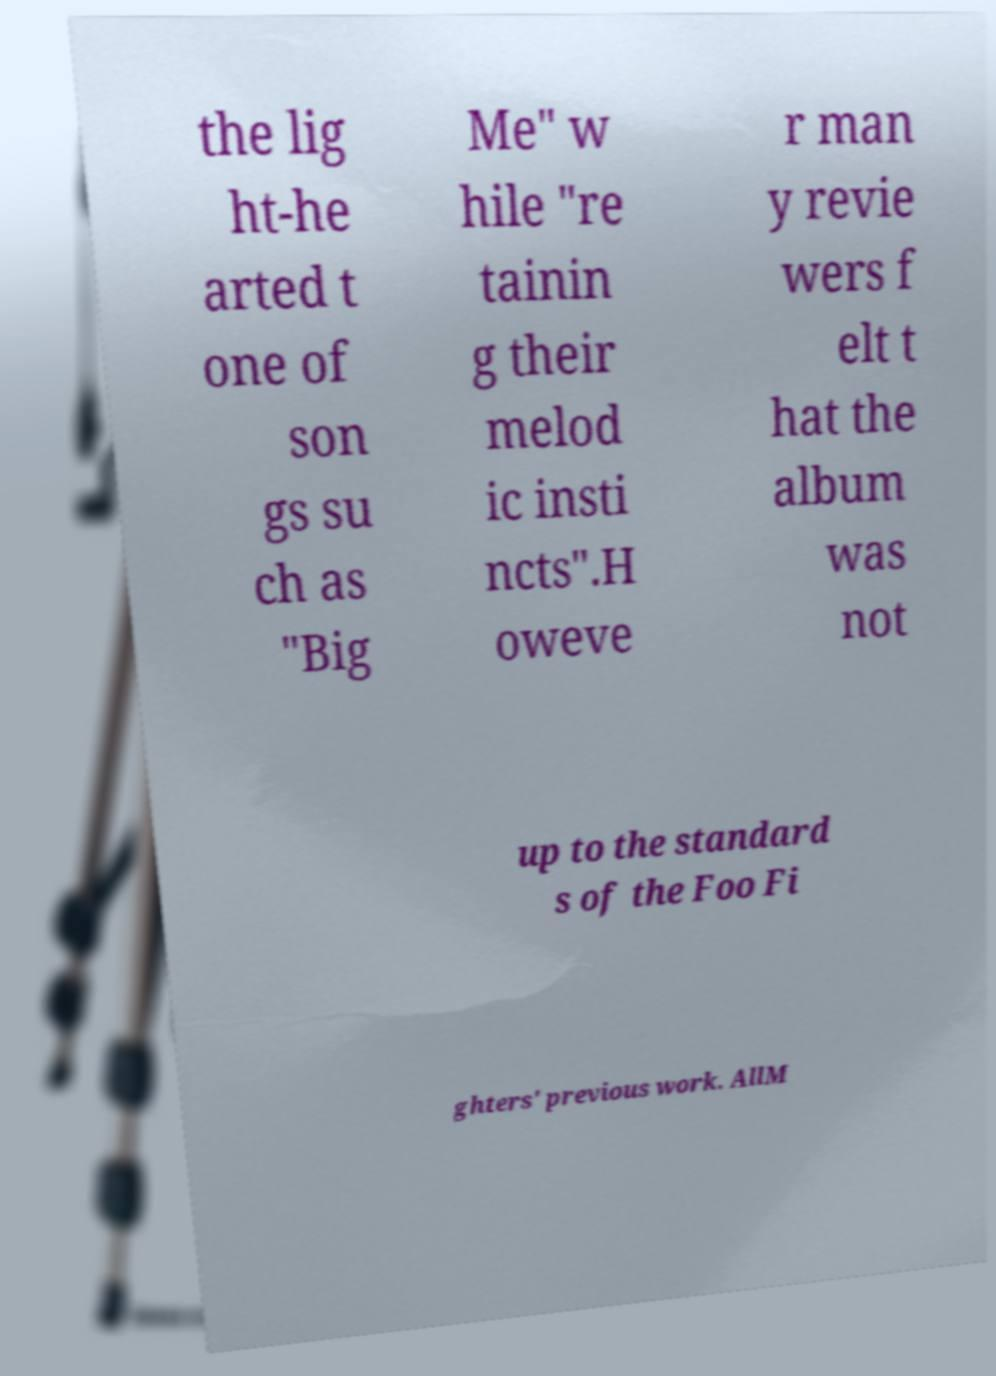Could you assist in decoding the text presented in this image and type it out clearly? the lig ht-he arted t one of son gs su ch as "Big Me" w hile "re tainin g their melod ic insti ncts".H oweve r man y revie wers f elt t hat the album was not up to the standard s of the Foo Fi ghters' previous work. AllM 